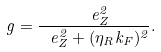Convert formula to latex. <formula><loc_0><loc_0><loc_500><loc_500>g = \frac { \ e _ { Z } ^ { 2 } } { \ e _ { Z } ^ { 2 } + ( \eta _ { R } k _ { F } ) ^ { 2 } } .</formula> 